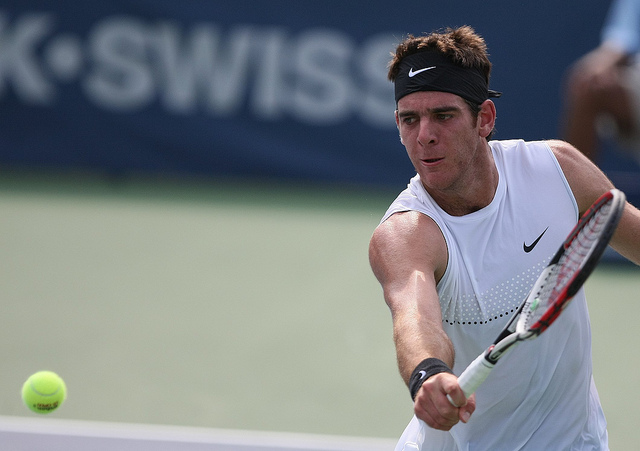<image>What famous athlete is playing tennis in the photo? I don't know which famous athlete is playing tennis in the photo. It could be Pete Sampras, Federer, or John Mcenroe. What famous athlete is playing tennis in the photo? I don't know which famous athlete is playing tennis in the photo. It can be Pete Sampras, Roger Federer, John McEnroe, or someone else. 